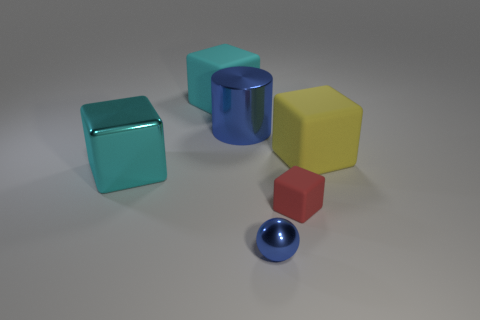Does the ball have the same size as the matte object that is behind the big yellow rubber thing?
Make the answer very short. No. Are there more metal cylinders that are in front of the large cyan rubber thing than tiny blue metal things?
Offer a terse response. No. How many other blue balls are the same size as the blue ball?
Provide a short and direct response. 0. Does the blue object in front of the blue shiny cylinder have the same size as the rubber thing on the left side of the metal cylinder?
Your answer should be very brief. No. Are there more cubes in front of the yellow object than large blocks to the left of the tiny blue object?
Offer a very short reply. No. What number of other things are the same shape as the cyan matte object?
Ensure brevity in your answer.  3. There is a blue thing that is the same size as the shiny cube; what is its material?
Your response must be concise. Metal. Are there any yellow things made of the same material as the big cylinder?
Provide a short and direct response. No. Is the number of rubber blocks to the right of the blue metallic sphere less than the number of big cyan matte objects?
Your answer should be compact. No. What is the material of the large cyan object behind the blue cylinder that is to the left of the large yellow rubber thing?
Provide a short and direct response. Rubber. 